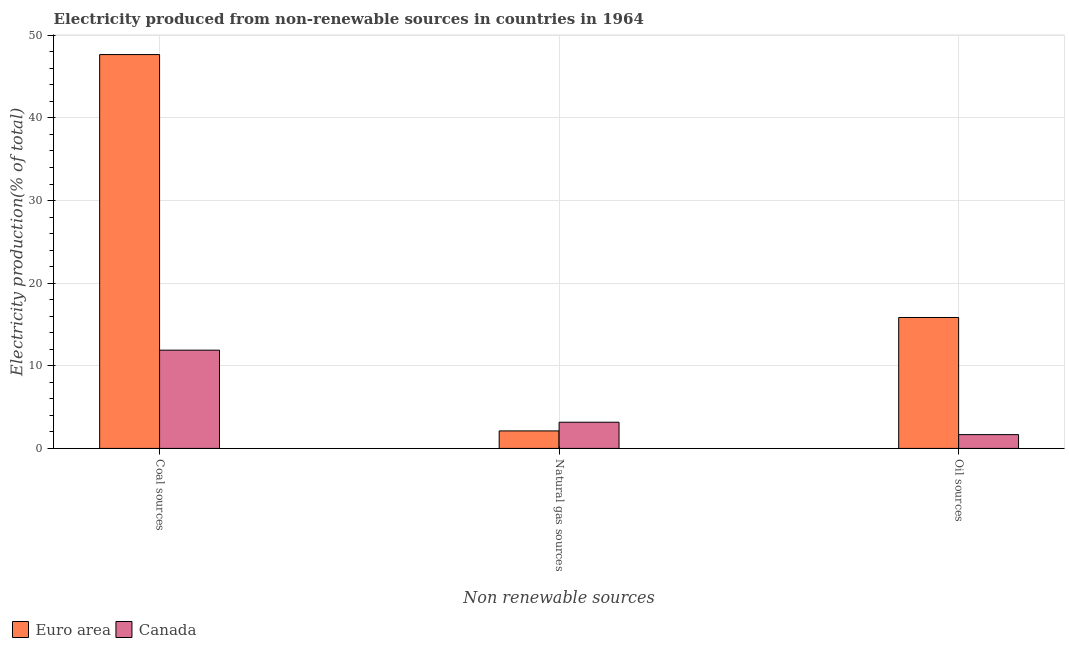Are the number of bars on each tick of the X-axis equal?
Keep it short and to the point. Yes. What is the label of the 2nd group of bars from the left?
Provide a short and direct response. Natural gas sources. What is the percentage of electricity produced by oil sources in Euro area?
Your answer should be compact. 15.85. Across all countries, what is the maximum percentage of electricity produced by coal?
Your answer should be very brief. 47.67. Across all countries, what is the minimum percentage of electricity produced by oil sources?
Your answer should be very brief. 1.67. What is the total percentage of electricity produced by coal in the graph?
Offer a very short reply. 59.56. What is the difference between the percentage of electricity produced by coal in Canada and that in Euro area?
Offer a terse response. -35.78. What is the difference between the percentage of electricity produced by coal in Canada and the percentage of electricity produced by natural gas in Euro area?
Give a very brief answer. 9.77. What is the average percentage of electricity produced by oil sources per country?
Provide a short and direct response. 8.76. What is the difference between the percentage of electricity produced by natural gas and percentage of electricity produced by coal in Euro area?
Give a very brief answer. -45.55. What is the ratio of the percentage of electricity produced by coal in Canada to that in Euro area?
Offer a terse response. 0.25. Is the percentage of electricity produced by natural gas in Canada less than that in Euro area?
Give a very brief answer. No. What is the difference between the highest and the second highest percentage of electricity produced by oil sources?
Offer a very short reply. 14.18. What is the difference between the highest and the lowest percentage of electricity produced by natural gas?
Make the answer very short. 1.05. Is it the case that in every country, the sum of the percentage of electricity produced by coal and percentage of electricity produced by natural gas is greater than the percentage of electricity produced by oil sources?
Your response must be concise. Yes. How many countries are there in the graph?
Your answer should be compact. 2. Where does the legend appear in the graph?
Offer a very short reply. Bottom left. How are the legend labels stacked?
Provide a short and direct response. Horizontal. What is the title of the graph?
Offer a terse response. Electricity produced from non-renewable sources in countries in 1964. What is the label or title of the X-axis?
Offer a very short reply. Non renewable sources. What is the label or title of the Y-axis?
Your answer should be compact. Electricity production(% of total). What is the Electricity production(% of total) of Euro area in Coal sources?
Give a very brief answer. 47.67. What is the Electricity production(% of total) of Canada in Coal sources?
Ensure brevity in your answer.  11.89. What is the Electricity production(% of total) in Euro area in Natural gas sources?
Your response must be concise. 2.12. What is the Electricity production(% of total) in Canada in Natural gas sources?
Ensure brevity in your answer.  3.17. What is the Electricity production(% of total) in Euro area in Oil sources?
Provide a succinct answer. 15.85. What is the Electricity production(% of total) of Canada in Oil sources?
Your answer should be very brief. 1.67. Across all Non renewable sources, what is the maximum Electricity production(% of total) in Euro area?
Offer a terse response. 47.67. Across all Non renewable sources, what is the maximum Electricity production(% of total) of Canada?
Provide a short and direct response. 11.89. Across all Non renewable sources, what is the minimum Electricity production(% of total) of Euro area?
Provide a succinct answer. 2.12. Across all Non renewable sources, what is the minimum Electricity production(% of total) in Canada?
Offer a very short reply. 1.67. What is the total Electricity production(% of total) in Euro area in the graph?
Your answer should be compact. 65.63. What is the total Electricity production(% of total) in Canada in the graph?
Make the answer very short. 16.73. What is the difference between the Electricity production(% of total) in Euro area in Coal sources and that in Natural gas sources?
Ensure brevity in your answer.  45.55. What is the difference between the Electricity production(% of total) of Canada in Coal sources and that in Natural gas sources?
Your answer should be very brief. 8.72. What is the difference between the Electricity production(% of total) of Euro area in Coal sources and that in Oil sources?
Offer a terse response. 31.82. What is the difference between the Electricity production(% of total) of Canada in Coal sources and that in Oil sources?
Your response must be concise. 10.22. What is the difference between the Electricity production(% of total) in Euro area in Natural gas sources and that in Oil sources?
Your answer should be compact. -13.73. What is the difference between the Electricity production(% of total) of Canada in Natural gas sources and that in Oil sources?
Your answer should be very brief. 1.5. What is the difference between the Electricity production(% of total) in Euro area in Coal sources and the Electricity production(% of total) in Canada in Natural gas sources?
Keep it short and to the point. 44.5. What is the difference between the Electricity production(% of total) in Euro area in Coal sources and the Electricity production(% of total) in Canada in Oil sources?
Your response must be concise. 46. What is the difference between the Electricity production(% of total) of Euro area in Natural gas sources and the Electricity production(% of total) of Canada in Oil sources?
Make the answer very short. 0.45. What is the average Electricity production(% of total) of Euro area per Non renewable sources?
Your answer should be very brief. 21.88. What is the average Electricity production(% of total) in Canada per Non renewable sources?
Give a very brief answer. 5.58. What is the difference between the Electricity production(% of total) of Euro area and Electricity production(% of total) of Canada in Coal sources?
Offer a very short reply. 35.78. What is the difference between the Electricity production(% of total) in Euro area and Electricity production(% of total) in Canada in Natural gas sources?
Offer a very short reply. -1.05. What is the difference between the Electricity production(% of total) of Euro area and Electricity production(% of total) of Canada in Oil sources?
Ensure brevity in your answer.  14.18. What is the ratio of the Electricity production(% of total) in Euro area in Coal sources to that in Natural gas sources?
Your response must be concise. 22.5. What is the ratio of the Electricity production(% of total) of Canada in Coal sources to that in Natural gas sources?
Keep it short and to the point. 3.75. What is the ratio of the Electricity production(% of total) of Euro area in Coal sources to that in Oil sources?
Ensure brevity in your answer.  3.01. What is the ratio of the Electricity production(% of total) of Canada in Coal sources to that in Oil sources?
Ensure brevity in your answer.  7.13. What is the ratio of the Electricity production(% of total) of Euro area in Natural gas sources to that in Oil sources?
Ensure brevity in your answer.  0.13. What is the ratio of the Electricity production(% of total) of Canada in Natural gas sources to that in Oil sources?
Keep it short and to the point. 1.9. What is the difference between the highest and the second highest Electricity production(% of total) in Euro area?
Your answer should be compact. 31.82. What is the difference between the highest and the second highest Electricity production(% of total) of Canada?
Ensure brevity in your answer.  8.72. What is the difference between the highest and the lowest Electricity production(% of total) of Euro area?
Give a very brief answer. 45.55. What is the difference between the highest and the lowest Electricity production(% of total) of Canada?
Offer a very short reply. 10.22. 